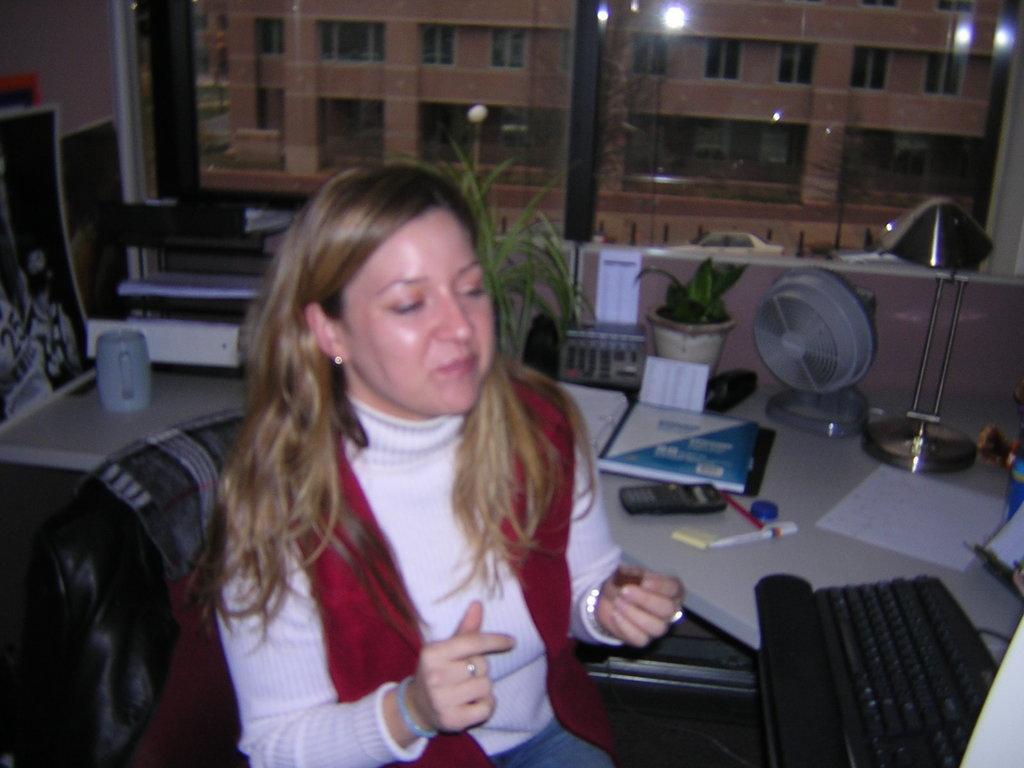Can you describe this image briefly? In this picture I can see a woman sitting on the chair, there are books, papers, pen, calculator, cup, table fan, plant, keyboard and some other objects on the table, there is a window, and in the background there is a building. 